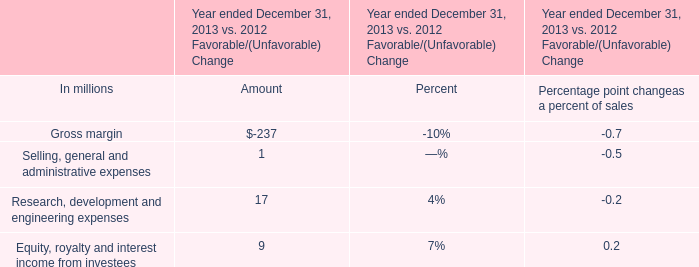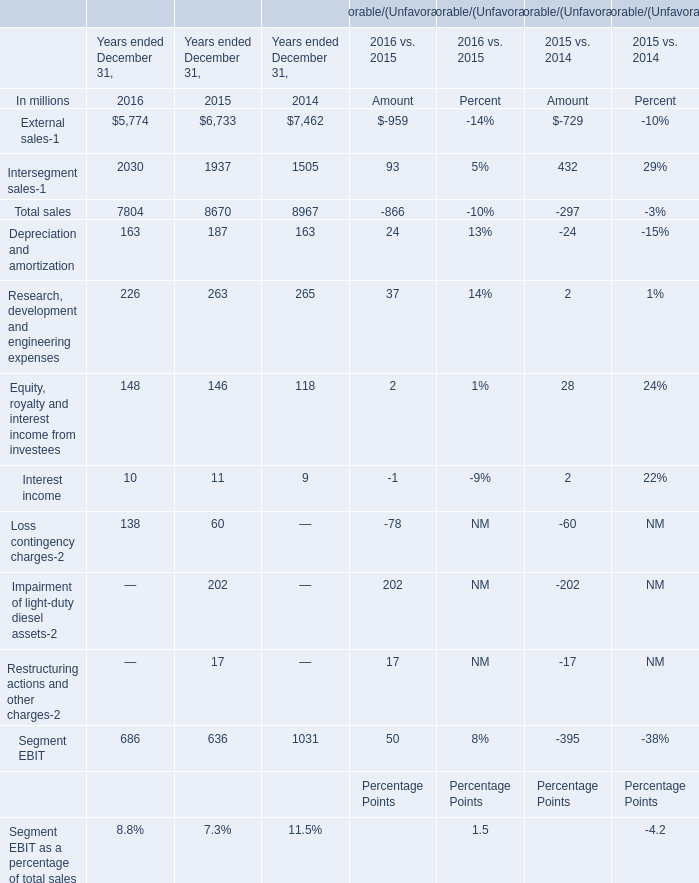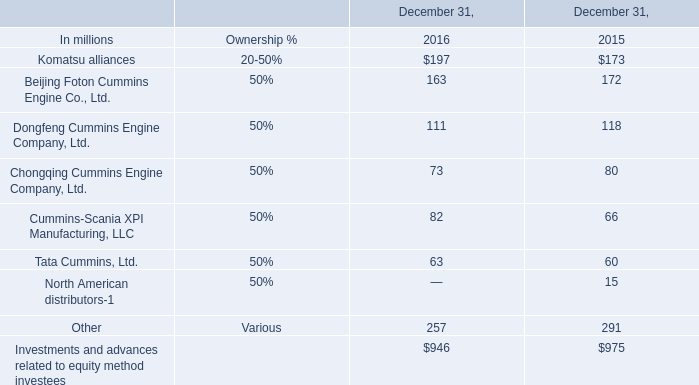What do all sales sum up without those sales smaller than 3000, in 2016? (in million) 
Answer: 5774. 